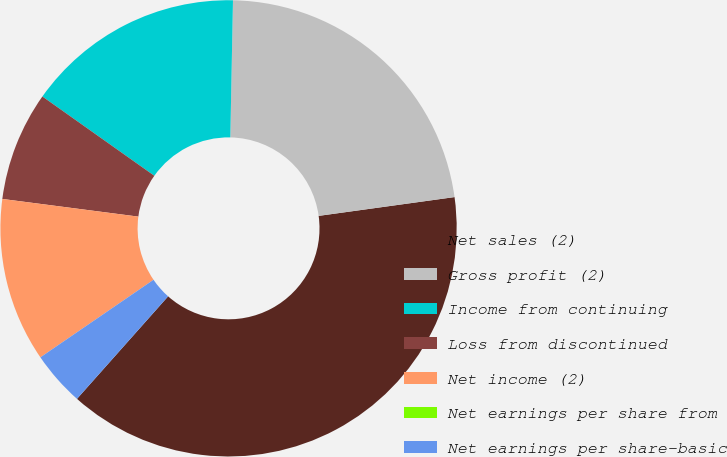Convert chart to OTSL. <chart><loc_0><loc_0><loc_500><loc_500><pie_chart><fcel>Net sales (2)<fcel>Gross profit (2)<fcel>Income from continuing<fcel>Loss from discontinued<fcel>Net income (2)<fcel>Net earnings per share from<fcel>Net earnings per share-basic<nl><fcel>38.75%<fcel>22.5%<fcel>15.5%<fcel>7.75%<fcel>11.62%<fcel>0.0%<fcel>3.87%<nl></chart> 